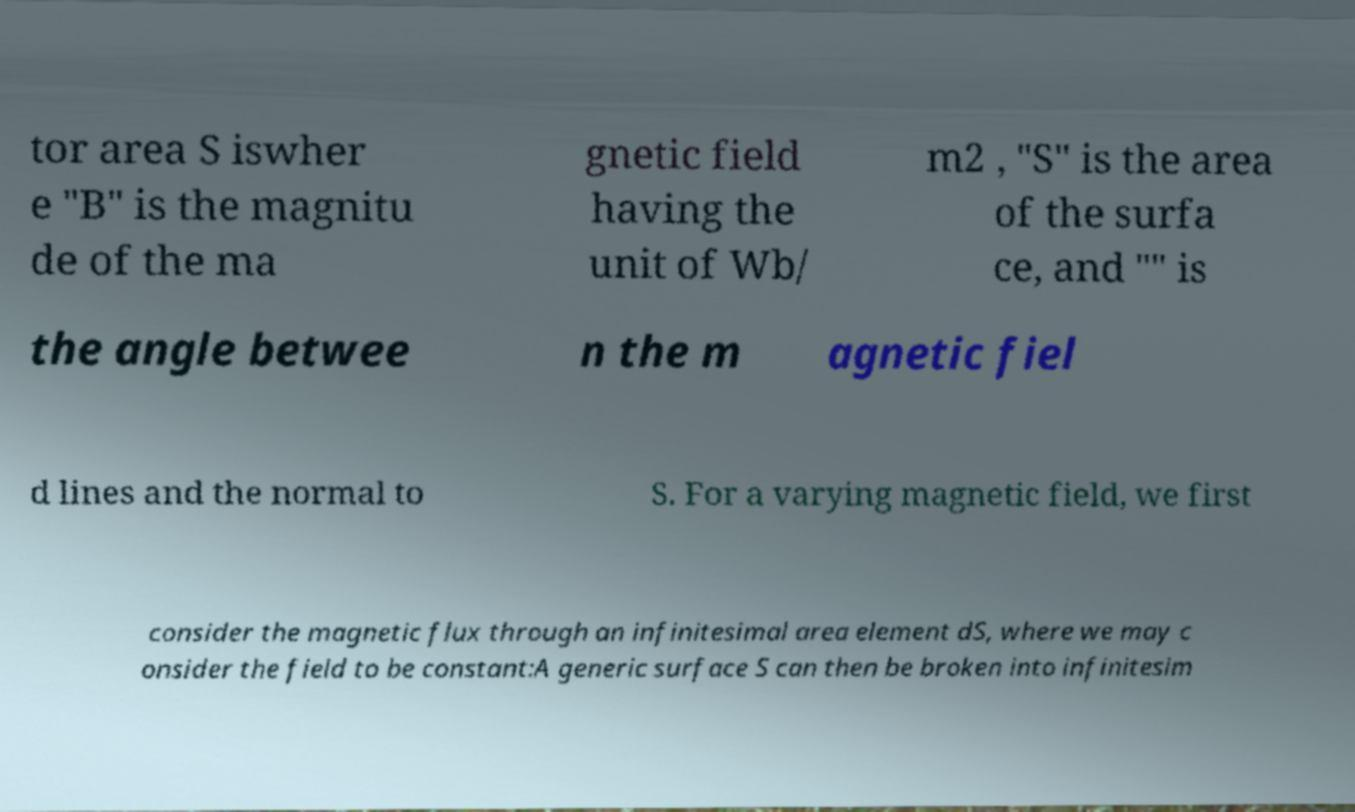Can you accurately transcribe the text from the provided image for me? tor area S iswher e "B" is the magnitu de of the ma gnetic field having the unit of Wb/ m2 , "S" is the area of the surfa ce, and "" is the angle betwee n the m agnetic fiel d lines and the normal to S. For a varying magnetic field, we first consider the magnetic flux through an infinitesimal area element dS, where we may c onsider the field to be constant:A generic surface S can then be broken into infinitesim 